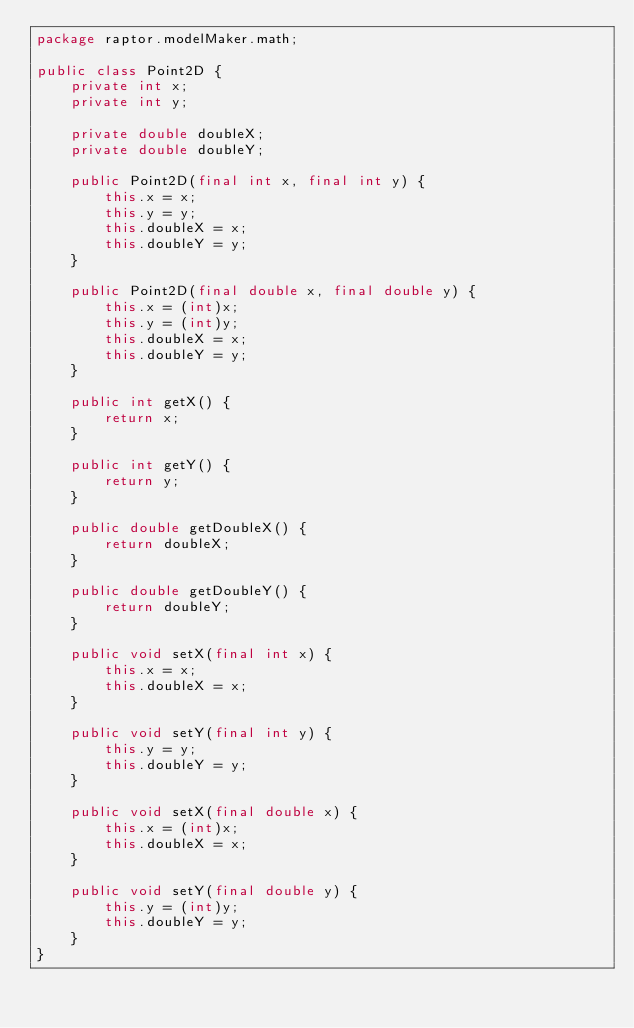<code> <loc_0><loc_0><loc_500><loc_500><_Java_>package raptor.modelMaker.math;

public class Point2D {
	private int x;
	private int y;

	private double doubleX;
	private double doubleY;

	public Point2D(final int x, final int y) {
		this.x = x;
		this.y = y;
		this.doubleX = x;
		this.doubleY = y;
	}

	public Point2D(final double x, final double y) {
		this.x = (int)x;
		this.y = (int)y;
		this.doubleX = x;
		this.doubleY = y;
	}

	public int getX() {
		return x;
	}

	public int getY() {
		return y;
	}

	public double getDoubleX() {
		return doubleX;
	}

	public double getDoubleY() {
		return doubleY;
	}

	public void setX(final int x) {
		this.x = x;
		this.doubleX = x;
	}

	public void setY(final int y) {
		this.y = y;
		this.doubleY = y;
	}

	public void setX(final double x) {
		this.x = (int)x;
		this.doubleX = x;
	}

	public void setY(final double y) {
		this.y = (int)y;
		this.doubleY = y;
	}
}
</code> 